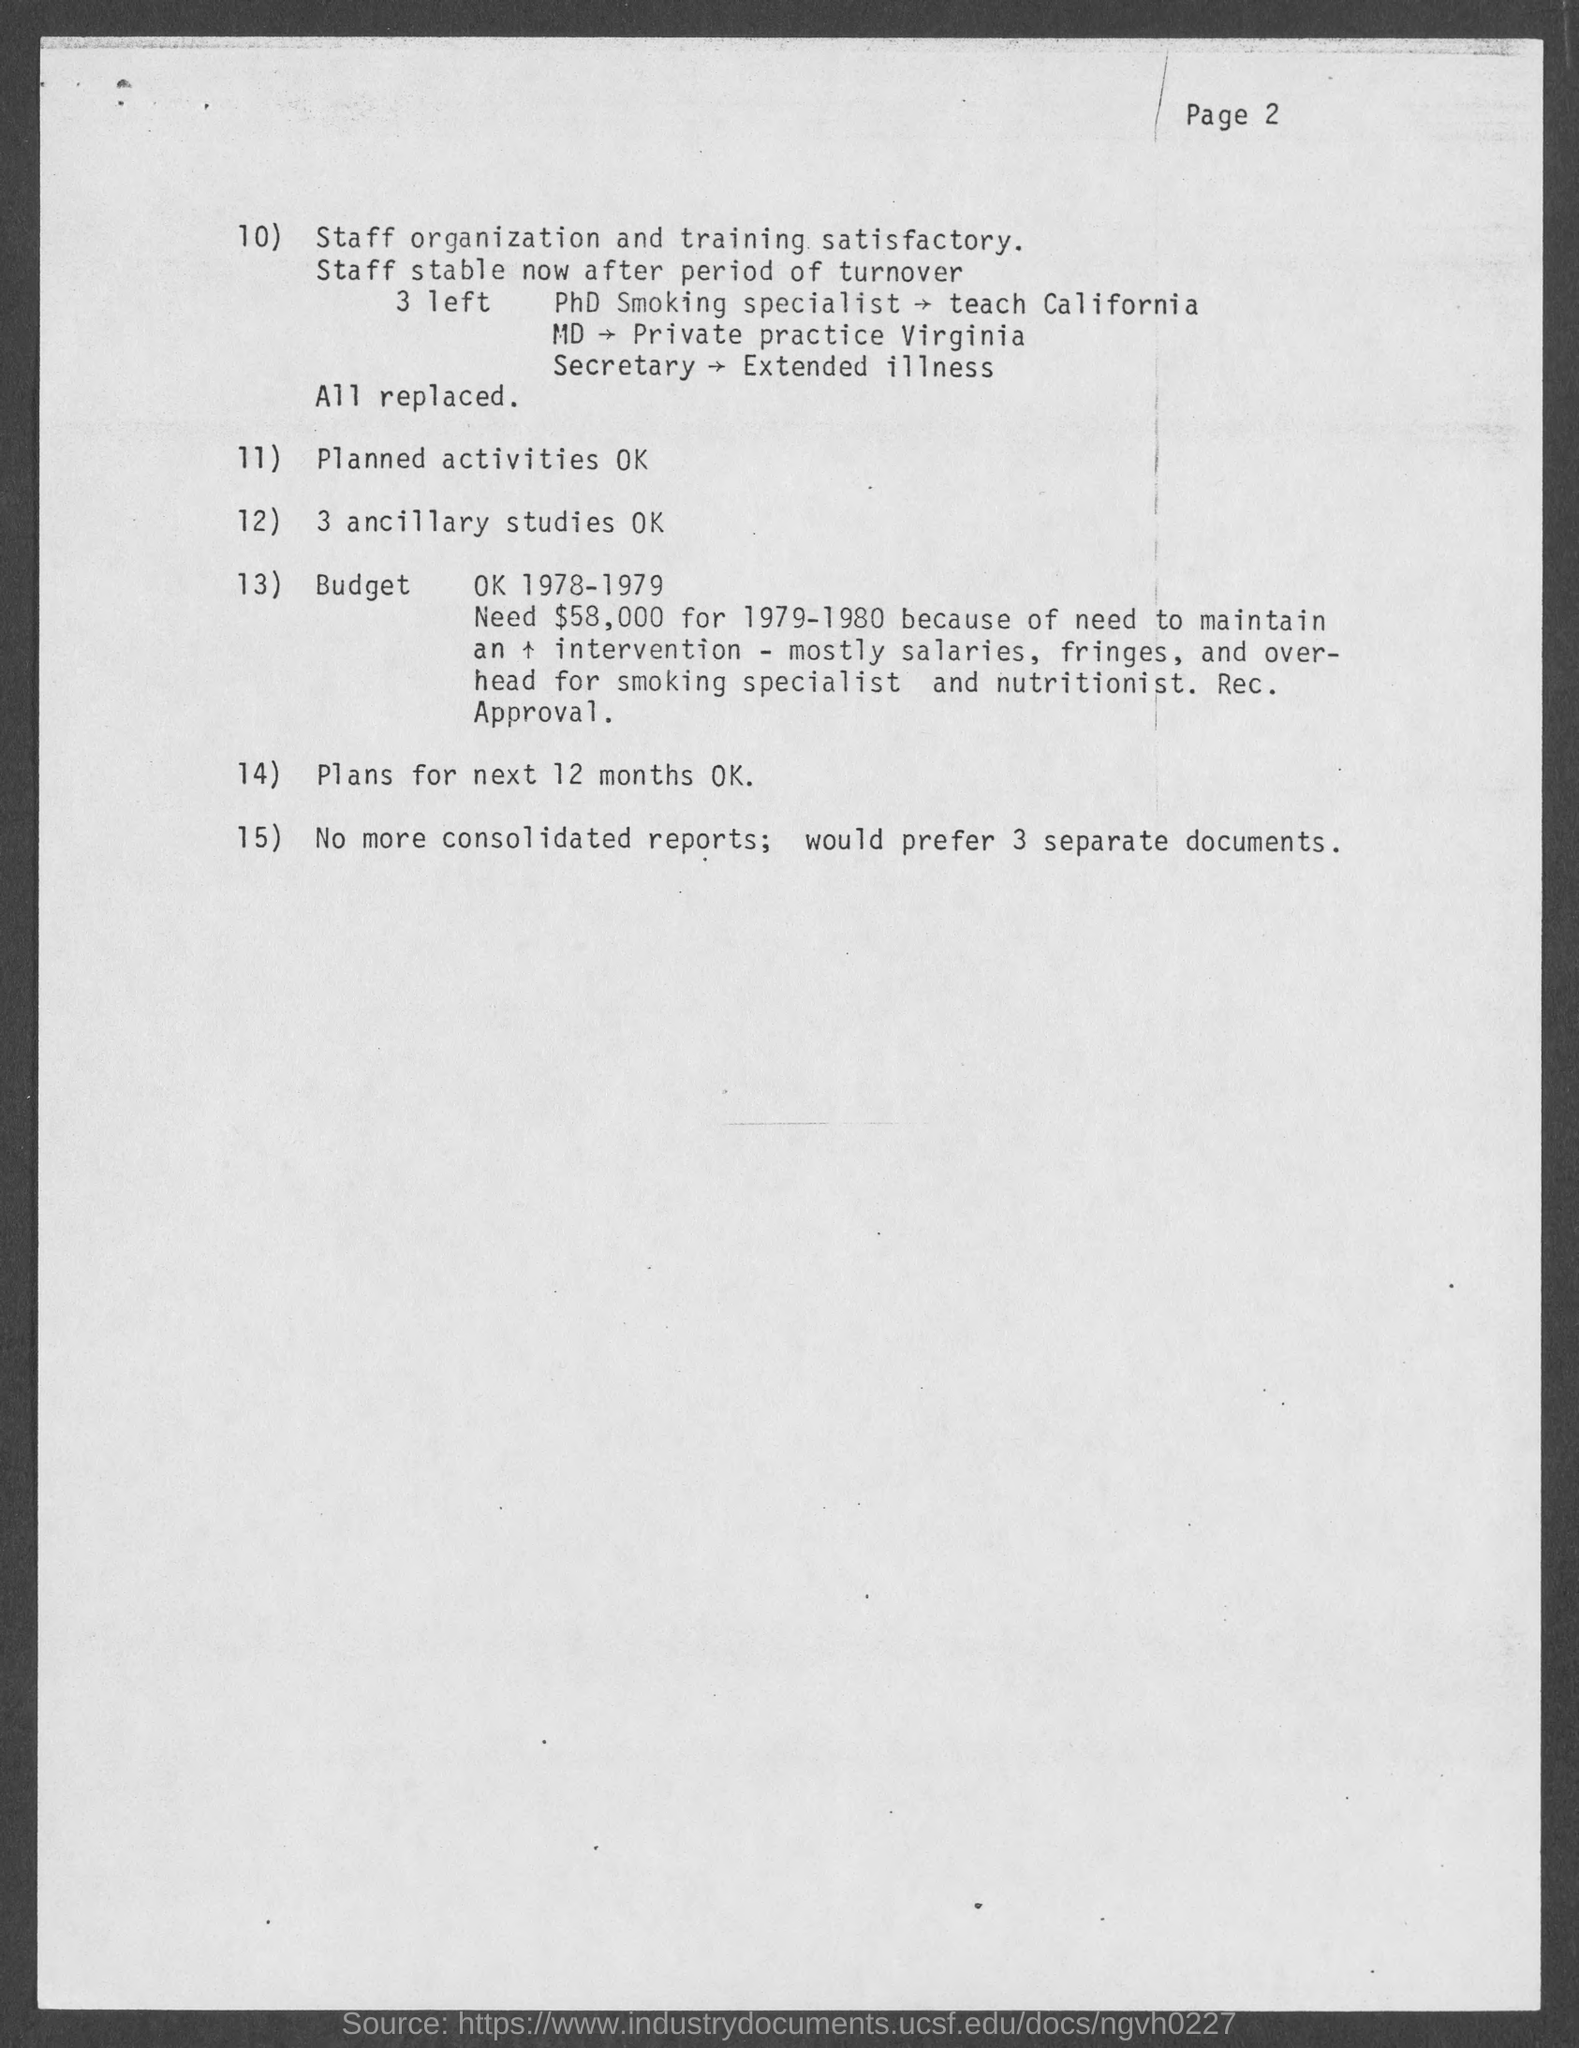What is the reason for which the secretary left?
Ensure brevity in your answer.  Extended illness. Plan for how many months is mentioned in the document?
Provide a succinct answer. 12 months. 